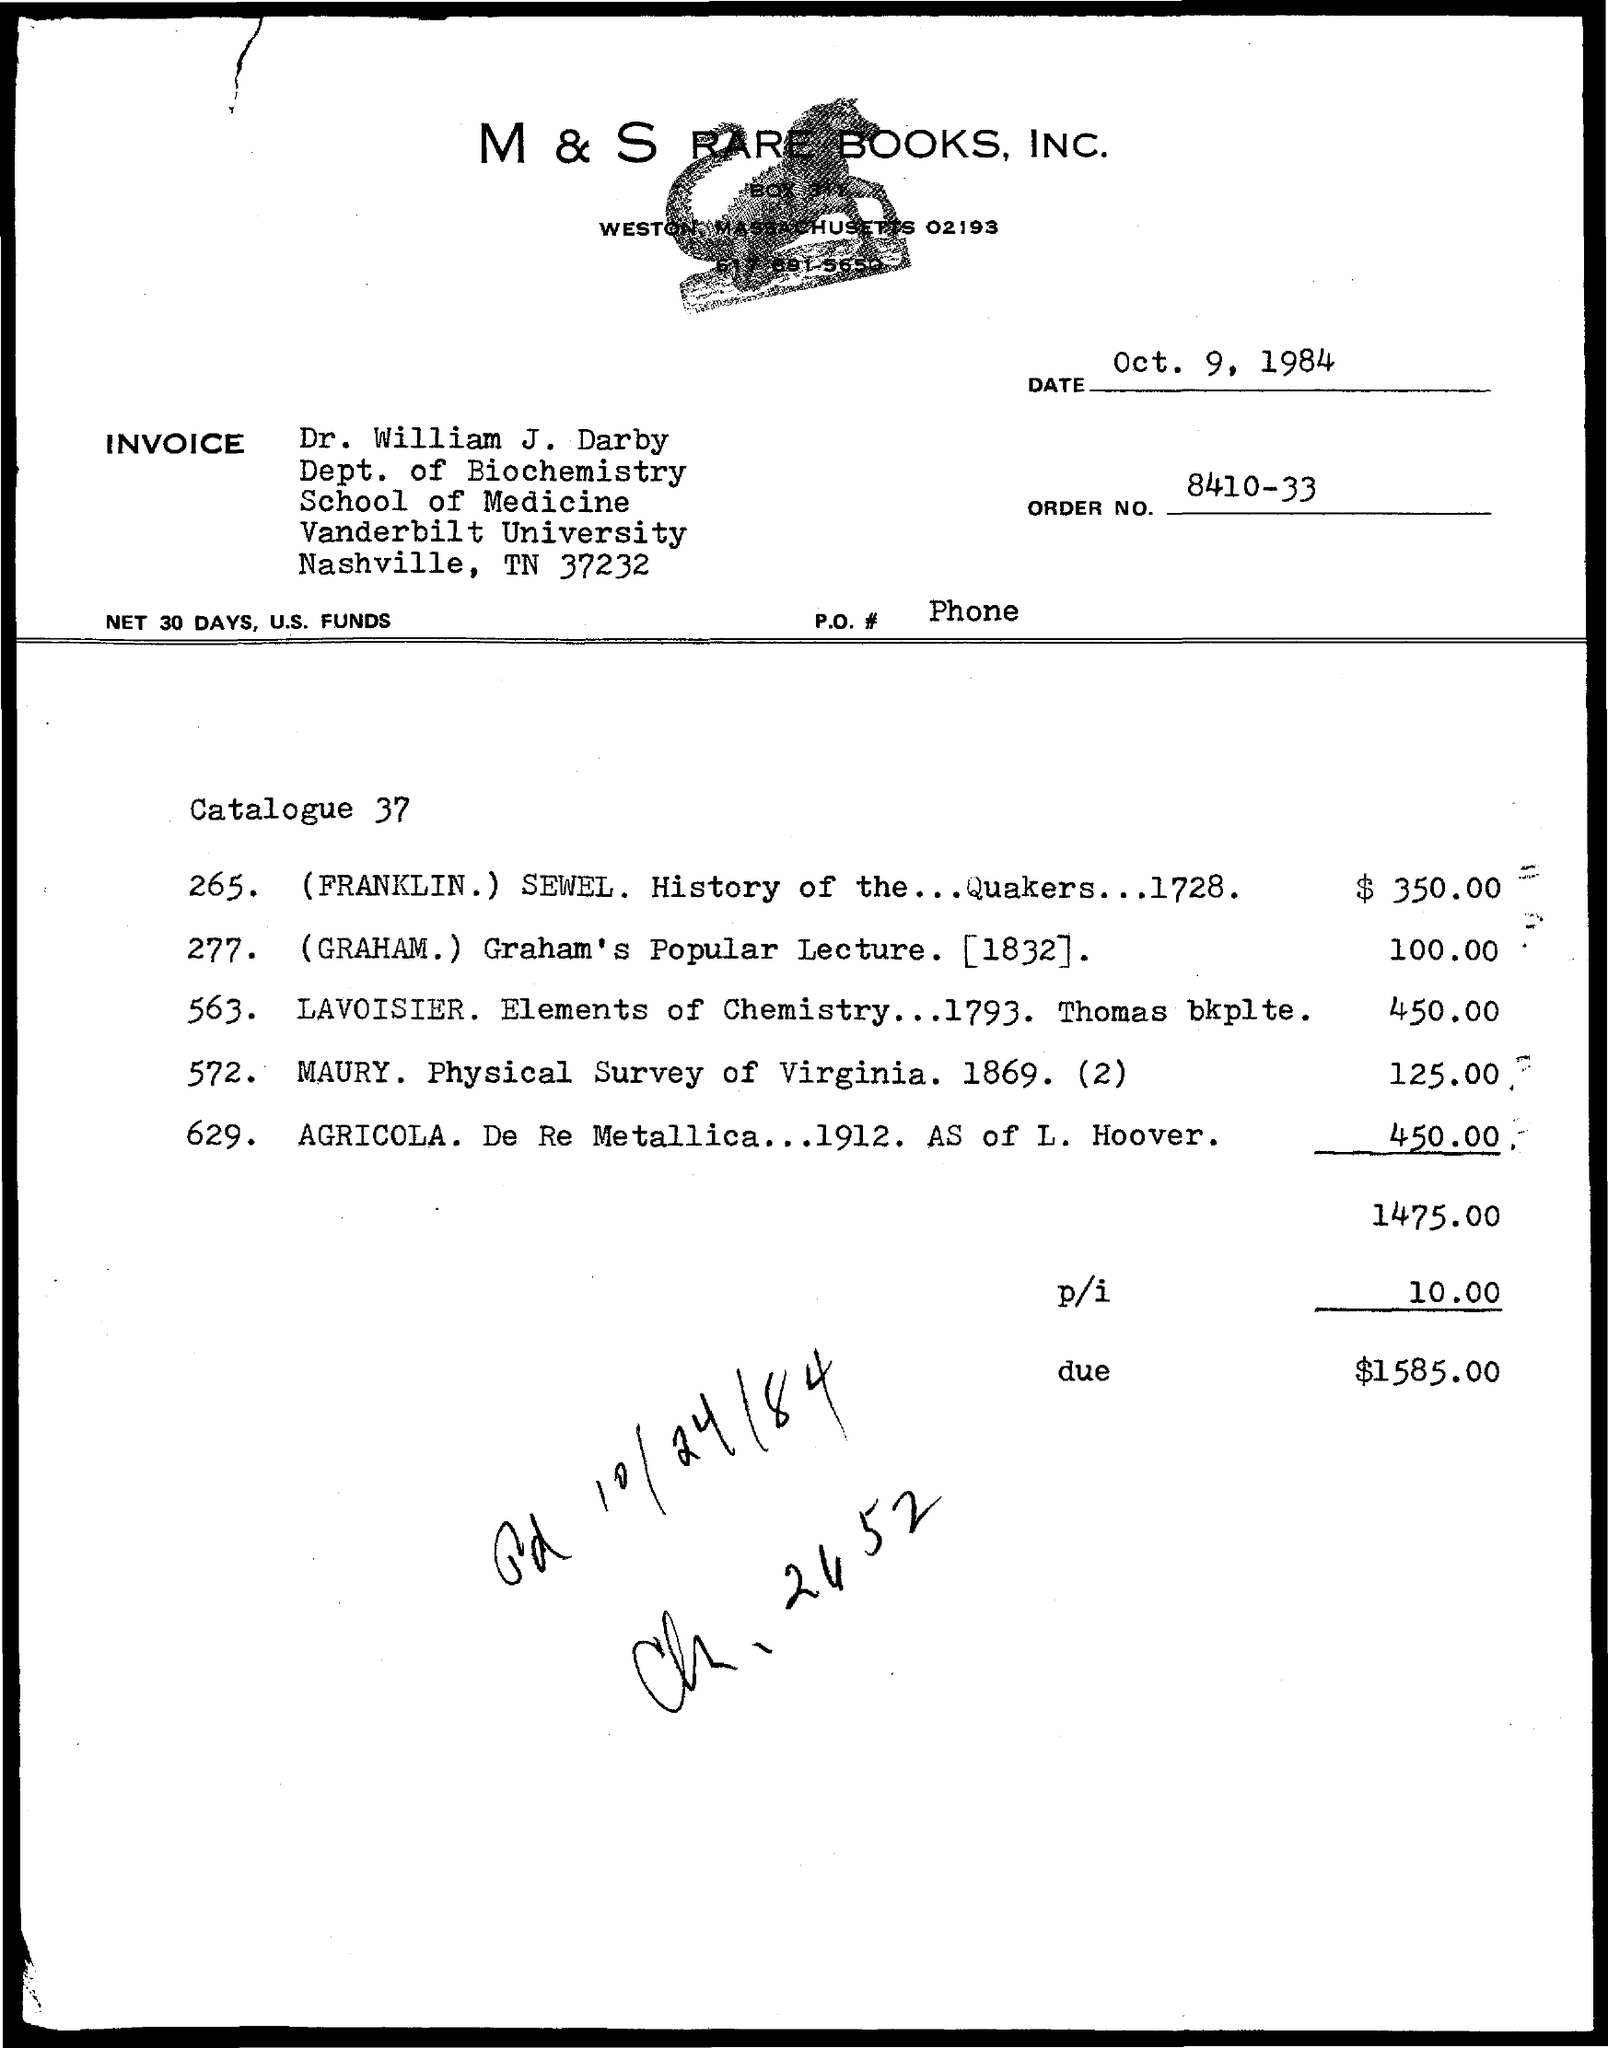List a handful of essential elements in this visual. The due amount mentioned on the given page is $1,585.00. Vanderbilt University is named in the provided page. The date mentioned in the given page is October 9, 1984. Dr. William J. Darby belongs to the department of biochemistry. The given page does not mention the order number. 